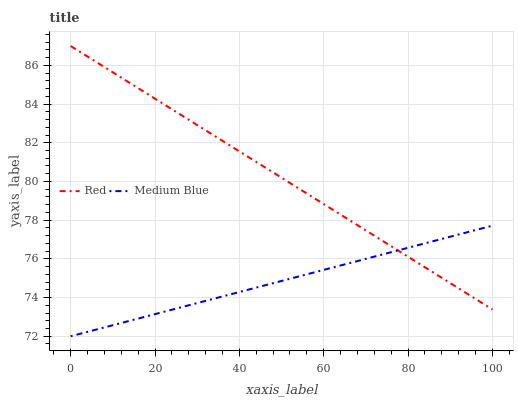Does Medium Blue have the minimum area under the curve?
Answer yes or no. Yes. Does Red have the maximum area under the curve?
Answer yes or no. Yes. Does Red have the minimum area under the curve?
Answer yes or no. No. Is Medium Blue the smoothest?
Answer yes or no. Yes. Is Red the roughest?
Answer yes or no. Yes. Is Red the smoothest?
Answer yes or no. No. Does Medium Blue have the lowest value?
Answer yes or no. Yes. Does Red have the lowest value?
Answer yes or no. No. Does Red have the highest value?
Answer yes or no. Yes. Does Medium Blue intersect Red?
Answer yes or no. Yes. Is Medium Blue less than Red?
Answer yes or no. No. Is Medium Blue greater than Red?
Answer yes or no. No. 